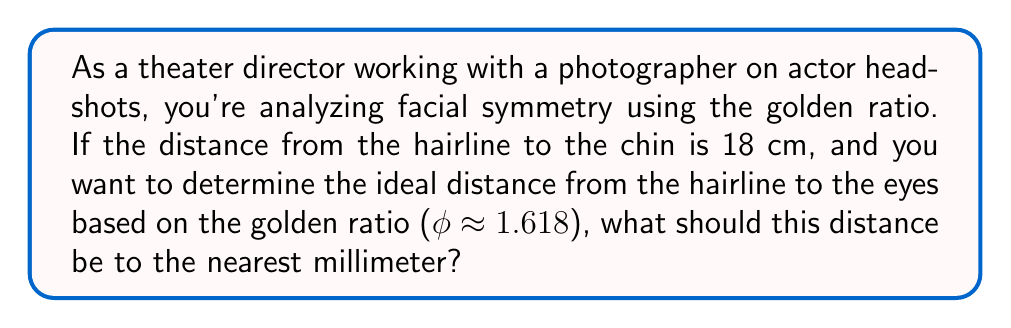Can you solve this math problem? To solve this problem, we need to use the properties of the golden ratio and apply it to facial proportions. Let's break it down step-by-step:

1) The golden ratio, denoted by φ (phi), is approximately 1.618.

2) In facial symmetry analysis, the golden ratio is often applied to various facial measurements. In this case, we're focusing on the vertical proportions of the face.

3) The total face length (hairline to chin) is given as 18 cm.

4) According to the golden ratio principle, the ratio of the whole length to the larger part should be equal to the ratio of the larger part to the smaller part.

5) Let x be the distance from the hairline to the eyes (the smaller part). Then (18 - x) would be the distance from the eyes to the chin (the larger part).

6) We can set up the following equation based on the golden ratio:

   $$\frac{18}{18-x} = \frac{18-x}{x} = φ ≈ 1.618$$

7) Focusing on the first equality:

   $$\frac{18}{18-x} = 1.618$$

8) Cross-multiply:

   $$18 = 1.618(18-x)$$
   $$18 = 29.124 - 1.618x$$

9) Solve for x:

   $$1.618x = 29.124 - 18$$
   $$1.618x = 11.124$$
   $$x = \frac{11.124}{1.618} ≈ 6.875$$

10) Convert to millimeters:
    6.875 cm = 68.75 mm

11) Rounding to the nearest millimeter:
    68.75 mm ≈ 69 mm
Answer: 69 mm 